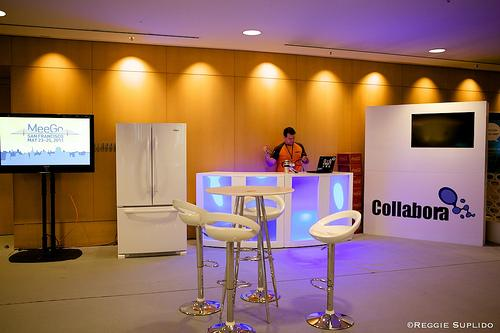Identify the type of event happening in the image. This appears to be some sort of exhibition. Can you find any devices in the image, and where are they placed? There is a black laptop placed on the counter. Describe the lighting situation in the image. There are multiple lights on the wall and some lights shining down from the ceiling. Count the number of light fixtures visible in the image. There are 9 light fixtures on the walls and one fire sprinkler. Mention the main piece of furniture seen in the image. A high table with 4 ultra-modern type chairs. What kind of appliance can you see in the image and what are its specifications? A white two-door refrigerator with a freezer. What is written on one of the boards in the image? One of the boards says "collabora". Provide a detailed description of a technological object in the image. There is a flat screen television on a stand with a black screen and silver edges. Give a brief description of the person in the image including their clothing. There is a man standing behind the counter who wears an orange and black shirt. Describe an interesting object in the image and its details. There are white chairs with a unique design feature - a hole in the center of their backrest. 